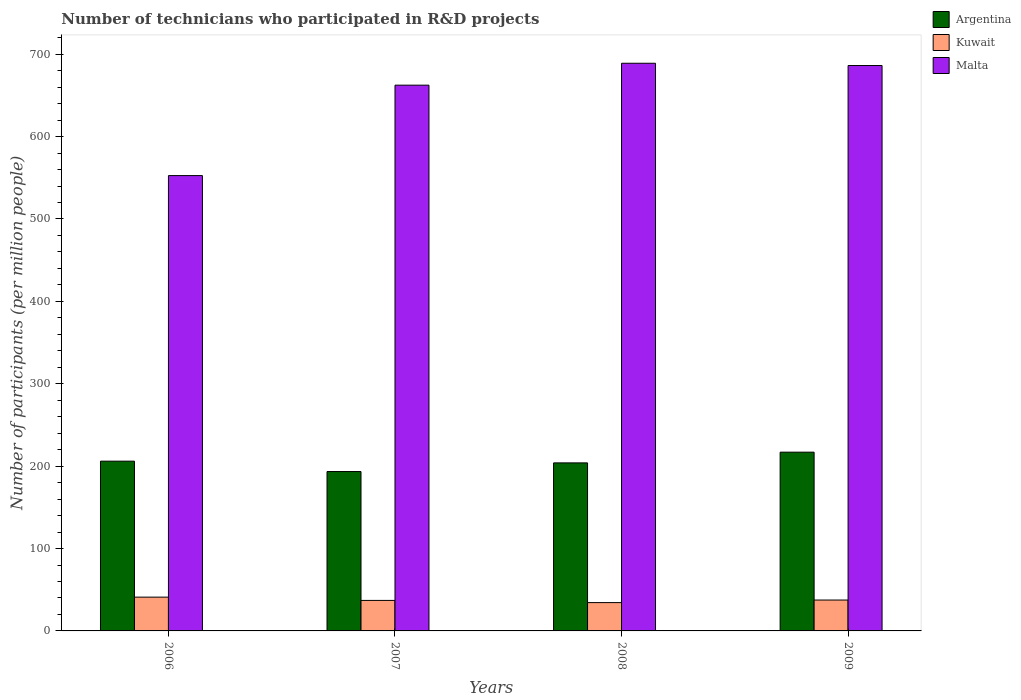How many different coloured bars are there?
Keep it short and to the point. 3. Are the number of bars per tick equal to the number of legend labels?
Offer a terse response. Yes. Are the number of bars on each tick of the X-axis equal?
Provide a short and direct response. Yes. How many bars are there on the 3rd tick from the left?
Make the answer very short. 3. What is the label of the 3rd group of bars from the left?
Ensure brevity in your answer.  2008. In how many cases, is the number of bars for a given year not equal to the number of legend labels?
Offer a terse response. 0. What is the number of technicians who participated in R&D projects in Kuwait in 2009?
Ensure brevity in your answer.  37.48. Across all years, what is the maximum number of technicians who participated in R&D projects in Malta?
Offer a very short reply. 688.99. Across all years, what is the minimum number of technicians who participated in R&D projects in Argentina?
Offer a terse response. 193.45. In which year was the number of technicians who participated in R&D projects in Malta maximum?
Give a very brief answer. 2008. In which year was the number of technicians who participated in R&D projects in Argentina minimum?
Provide a short and direct response. 2007. What is the total number of technicians who participated in R&D projects in Kuwait in the graph?
Provide a succinct answer. 149.9. What is the difference between the number of technicians who participated in R&D projects in Kuwait in 2008 and that in 2009?
Keep it short and to the point. -3.11. What is the difference between the number of technicians who participated in R&D projects in Argentina in 2008 and the number of technicians who participated in R&D projects in Kuwait in 2006?
Your answer should be compact. 162.94. What is the average number of technicians who participated in R&D projects in Malta per year?
Your response must be concise. 647.57. In the year 2009, what is the difference between the number of technicians who participated in R&D projects in Kuwait and number of technicians who participated in R&D projects in Malta?
Make the answer very short. -648.76. What is the ratio of the number of technicians who participated in R&D projects in Malta in 2006 to that in 2009?
Give a very brief answer. 0.81. Is the number of technicians who participated in R&D projects in Malta in 2006 less than that in 2008?
Your answer should be compact. Yes. What is the difference between the highest and the second highest number of technicians who participated in R&D projects in Malta?
Make the answer very short. 2.75. What is the difference between the highest and the lowest number of technicians who participated in R&D projects in Argentina?
Your answer should be compact. 23.52. What does the 3rd bar from the right in 2007 represents?
Your response must be concise. Argentina. Is it the case that in every year, the sum of the number of technicians who participated in R&D projects in Argentina and number of technicians who participated in R&D projects in Malta is greater than the number of technicians who participated in R&D projects in Kuwait?
Offer a terse response. Yes. How many bars are there?
Give a very brief answer. 12. Are all the bars in the graph horizontal?
Offer a very short reply. No. Are the values on the major ticks of Y-axis written in scientific E-notation?
Provide a short and direct response. No. How many legend labels are there?
Keep it short and to the point. 3. What is the title of the graph?
Provide a succinct answer. Number of technicians who participated in R&D projects. What is the label or title of the X-axis?
Ensure brevity in your answer.  Years. What is the label or title of the Y-axis?
Your answer should be very brief. Number of participants (per million people). What is the Number of participants (per million people) of Argentina in 2006?
Provide a short and direct response. 206.05. What is the Number of participants (per million people) of Kuwait in 2006?
Make the answer very short. 41.01. What is the Number of participants (per million people) of Malta in 2006?
Give a very brief answer. 552.65. What is the Number of participants (per million people) of Argentina in 2007?
Offer a very short reply. 193.45. What is the Number of participants (per million people) in Kuwait in 2007?
Your answer should be very brief. 37.03. What is the Number of participants (per million people) of Malta in 2007?
Your response must be concise. 662.41. What is the Number of participants (per million people) in Argentina in 2008?
Offer a very short reply. 203.95. What is the Number of participants (per million people) of Kuwait in 2008?
Provide a succinct answer. 34.38. What is the Number of participants (per million people) of Malta in 2008?
Your response must be concise. 688.99. What is the Number of participants (per million people) of Argentina in 2009?
Ensure brevity in your answer.  216.97. What is the Number of participants (per million people) of Kuwait in 2009?
Your response must be concise. 37.48. What is the Number of participants (per million people) of Malta in 2009?
Give a very brief answer. 686.24. Across all years, what is the maximum Number of participants (per million people) in Argentina?
Your response must be concise. 216.97. Across all years, what is the maximum Number of participants (per million people) of Kuwait?
Make the answer very short. 41.01. Across all years, what is the maximum Number of participants (per million people) of Malta?
Offer a very short reply. 688.99. Across all years, what is the minimum Number of participants (per million people) of Argentina?
Your response must be concise. 193.45. Across all years, what is the minimum Number of participants (per million people) in Kuwait?
Your response must be concise. 34.38. Across all years, what is the minimum Number of participants (per million people) in Malta?
Keep it short and to the point. 552.65. What is the total Number of participants (per million people) in Argentina in the graph?
Offer a terse response. 820.41. What is the total Number of participants (per million people) of Kuwait in the graph?
Ensure brevity in your answer.  149.9. What is the total Number of participants (per million people) of Malta in the graph?
Ensure brevity in your answer.  2590.29. What is the difference between the Number of participants (per million people) of Argentina in 2006 and that in 2007?
Offer a terse response. 12.6. What is the difference between the Number of participants (per million people) in Kuwait in 2006 and that in 2007?
Make the answer very short. 3.98. What is the difference between the Number of participants (per million people) in Malta in 2006 and that in 2007?
Give a very brief answer. -109.76. What is the difference between the Number of participants (per million people) in Argentina in 2006 and that in 2008?
Your answer should be very brief. 2.1. What is the difference between the Number of participants (per million people) in Kuwait in 2006 and that in 2008?
Keep it short and to the point. 6.64. What is the difference between the Number of participants (per million people) in Malta in 2006 and that in 2008?
Provide a succinct answer. -136.34. What is the difference between the Number of participants (per million people) of Argentina in 2006 and that in 2009?
Give a very brief answer. -10.92. What is the difference between the Number of participants (per million people) of Kuwait in 2006 and that in 2009?
Offer a terse response. 3.53. What is the difference between the Number of participants (per million people) in Malta in 2006 and that in 2009?
Provide a succinct answer. -133.6. What is the difference between the Number of participants (per million people) of Argentina in 2007 and that in 2008?
Your answer should be very brief. -10.51. What is the difference between the Number of participants (per million people) of Kuwait in 2007 and that in 2008?
Offer a terse response. 2.65. What is the difference between the Number of participants (per million people) in Malta in 2007 and that in 2008?
Keep it short and to the point. -26.58. What is the difference between the Number of participants (per million people) in Argentina in 2007 and that in 2009?
Offer a terse response. -23.52. What is the difference between the Number of participants (per million people) in Kuwait in 2007 and that in 2009?
Offer a very short reply. -0.46. What is the difference between the Number of participants (per million people) in Malta in 2007 and that in 2009?
Offer a very short reply. -23.84. What is the difference between the Number of participants (per million people) of Argentina in 2008 and that in 2009?
Your answer should be very brief. -13.02. What is the difference between the Number of participants (per million people) of Kuwait in 2008 and that in 2009?
Offer a terse response. -3.11. What is the difference between the Number of participants (per million people) of Malta in 2008 and that in 2009?
Provide a short and direct response. 2.75. What is the difference between the Number of participants (per million people) of Argentina in 2006 and the Number of participants (per million people) of Kuwait in 2007?
Ensure brevity in your answer.  169.02. What is the difference between the Number of participants (per million people) in Argentina in 2006 and the Number of participants (per million people) in Malta in 2007?
Give a very brief answer. -456.36. What is the difference between the Number of participants (per million people) in Kuwait in 2006 and the Number of participants (per million people) in Malta in 2007?
Ensure brevity in your answer.  -621.39. What is the difference between the Number of participants (per million people) of Argentina in 2006 and the Number of participants (per million people) of Kuwait in 2008?
Give a very brief answer. 171.67. What is the difference between the Number of participants (per million people) in Argentina in 2006 and the Number of participants (per million people) in Malta in 2008?
Provide a succinct answer. -482.94. What is the difference between the Number of participants (per million people) in Kuwait in 2006 and the Number of participants (per million people) in Malta in 2008?
Make the answer very short. -647.98. What is the difference between the Number of participants (per million people) of Argentina in 2006 and the Number of participants (per million people) of Kuwait in 2009?
Your answer should be very brief. 168.56. What is the difference between the Number of participants (per million people) in Argentina in 2006 and the Number of participants (per million people) in Malta in 2009?
Provide a succinct answer. -480.2. What is the difference between the Number of participants (per million people) in Kuwait in 2006 and the Number of participants (per million people) in Malta in 2009?
Your answer should be very brief. -645.23. What is the difference between the Number of participants (per million people) of Argentina in 2007 and the Number of participants (per million people) of Kuwait in 2008?
Your response must be concise. 159.07. What is the difference between the Number of participants (per million people) of Argentina in 2007 and the Number of participants (per million people) of Malta in 2008?
Give a very brief answer. -495.54. What is the difference between the Number of participants (per million people) of Kuwait in 2007 and the Number of participants (per million people) of Malta in 2008?
Your response must be concise. -651.96. What is the difference between the Number of participants (per million people) of Argentina in 2007 and the Number of participants (per million people) of Kuwait in 2009?
Your answer should be very brief. 155.96. What is the difference between the Number of participants (per million people) in Argentina in 2007 and the Number of participants (per million people) in Malta in 2009?
Offer a very short reply. -492.8. What is the difference between the Number of participants (per million people) of Kuwait in 2007 and the Number of participants (per million people) of Malta in 2009?
Your answer should be compact. -649.22. What is the difference between the Number of participants (per million people) of Argentina in 2008 and the Number of participants (per million people) of Kuwait in 2009?
Keep it short and to the point. 166.47. What is the difference between the Number of participants (per million people) in Argentina in 2008 and the Number of participants (per million people) in Malta in 2009?
Provide a succinct answer. -482.29. What is the difference between the Number of participants (per million people) of Kuwait in 2008 and the Number of participants (per million people) of Malta in 2009?
Offer a terse response. -651.87. What is the average Number of participants (per million people) in Argentina per year?
Your response must be concise. 205.1. What is the average Number of participants (per million people) in Kuwait per year?
Your response must be concise. 37.48. What is the average Number of participants (per million people) of Malta per year?
Keep it short and to the point. 647.57. In the year 2006, what is the difference between the Number of participants (per million people) of Argentina and Number of participants (per million people) of Kuwait?
Offer a terse response. 165.04. In the year 2006, what is the difference between the Number of participants (per million people) in Argentina and Number of participants (per million people) in Malta?
Ensure brevity in your answer.  -346.6. In the year 2006, what is the difference between the Number of participants (per million people) in Kuwait and Number of participants (per million people) in Malta?
Provide a short and direct response. -511.64. In the year 2007, what is the difference between the Number of participants (per million people) of Argentina and Number of participants (per million people) of Kuwait?
Give a very brief answer. 156.42. In the year 2007, what is the difference between the Number of participants (per million people) in Argentina and Number of participants (per million people) in Malta?
Provide a short and direct response. -468.96. In the year 2007, what is the difference between the Number of participants (per million people) of Kuwait and Number of participants (per million people) of Malta?
Provide a short and direct response. -625.38. In the year 2008, what is the difference between the Number of participants (per million people) in Argentina and Number of participants (per million people) in Kuwait?
Provide a succinct answer. 169.58. In the year 2008, what is the difference between the Number of participants (per million people) of Argentina and Number of participants (per million people) of Malta?
Ensure brevity in your answer.  -485.04. In the year 2008, what is the difference between the Number of participants (per million people) in Kuwait and Number of participants (per million people) in Malta?
Make the answer very short. -654.61. In the year 2009, what is the difference between the Number of participants (per million people) of Argentina and Number of participants (per million people) of Kuwait?
Offer a terse response. 179.48. In the year 2009, what is the difference between the Number of participants (per million people) of Argentina and Number of participants (per million people) of Malta?
Your answer should be compact. -469.28. In the year 2009, what is the difference between the Number of participants (per million people) in Kuwait and Number of participants (per million people) in Malta?
Offer a very short reply. -648.76. What is the ratio of the Number of participants (per million people) of Argentina in 2006 to that in 2007?
Ensure brevity in your answer.  1.07. What is the ratio of the Number of participants (per million people) in Kuwait in 2006 to that in 2007?
Ensure brevity in your answer.  1.11. What is the ratio of the Number of participants (per million people) in Malta in 2006 to that in 2007?
Ensure brevity in your answer.  0.83. What is the ratio of the Number of participants (per million people) of Argentina in 2006 to that in 2008?
Make the answer very short. 1.01. What is the ratio of the Number of participants (per million people) in Kuwait in 2006 to that in 2008?
Provide a succinct answer. 1.19. What is the ratio of the Number of participants (per million people) in Malta in 2006 to that in 2008?
Provide a short and direct response. 0.8. What is the ratio of the Number of participants (per million people) of Argentina in 2006 to that in 2009?
Keep it short and to the point. 0.95. What is the ratio of the Number of participants (per million people) of Kuwait in 2006 to that in 2009?
Your answer should be very brief. 1.09. What is the ratio of the Number of participants (per million people) in Malta in 2006 to that in 2009?
Your response must be concise. 0.81. What is the ratio of the Number of participants (per million people) in Argentina in 2007 to that in 2008?
Offer a very short reply. 0.95. What is the ratio of the Number of participants (per million people) of Kuwait in 2007 to that in 2008?
Provide a succinct answer. 1.08. What is the ratio of the Number of participants (per million people) in Malta in 2007 to that in 2008?
Your response must be concise. 0.96. What is the ratio of the Number of participants (per million people) in Argentina in 2007 to that in 2009?
Your answer should be very brief. 0.89. What is the ratio of the Number of participants (per million people) of Kuwait in 2007 to that in 2009?
Your answer should be very brief. 0.99. What is the ratio of the Number of participants (per million people) of Malta in 2007 to that in 2009?
Offer a very short reply. 0.97. What is the ratio of the Number of participants (per million people) in Kuwait in 2008 to that in 2009?
Your answer should be very brief. 0.92. What is the difference between the highest and the second highest Number of participants (per million people) in Argentina?
Your answer should be compact. 10.92. What is the difference between the highest and the second highest Number of participants (per million people) of Kuwait?
Your answer should be very brief. 3.53. What is the difference between the highest and the second highest Number of participants (per million people) of Malta?
Provide a short and direct response. 2.75. What is the difference between the highest and the lowest Number of participants (per million people) in Argentina?
Your answer should be compact. 23.52. What is the difference between the highest and the lowest Number of participants (per million people) in Kuwait?
Offer a terse response. 6.64. What is the difference between the highest and the lowest Number of participants (per million people) of Malta?
Your answer should be very brief. 136.34. 